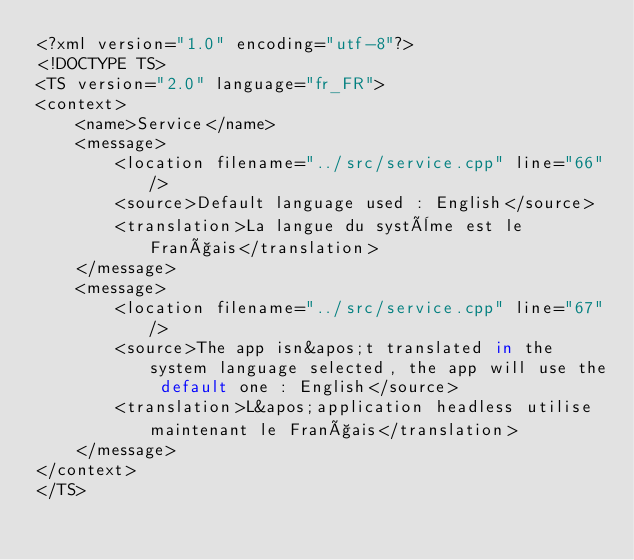Convert code to text. <code><loc_0><loc_0><loc_500><loc_500><_TypeScript_><?xml version="1.0" encoding="utf-8"?>
<!DOCTYPE TS>
<TS version="2.0" language="fr_FR">
<context>
    <name>Service</name>
    <message>
        <location filename="../src/service.cpp" line="66"/>
        <source>Default language used : English</source>
        <translation>La langue du système est le Français</translation>
    </message>
    <message>
        <location filename="../src/service.cpp" line="67"/>
        <source>The app isn&apos;t translated in the system language selected, the app will use the default one : English</source>
        <translation>L&apos;application headless utilise maintenant le Français</translation>
    </message>
</context>
</TS>
</code> 